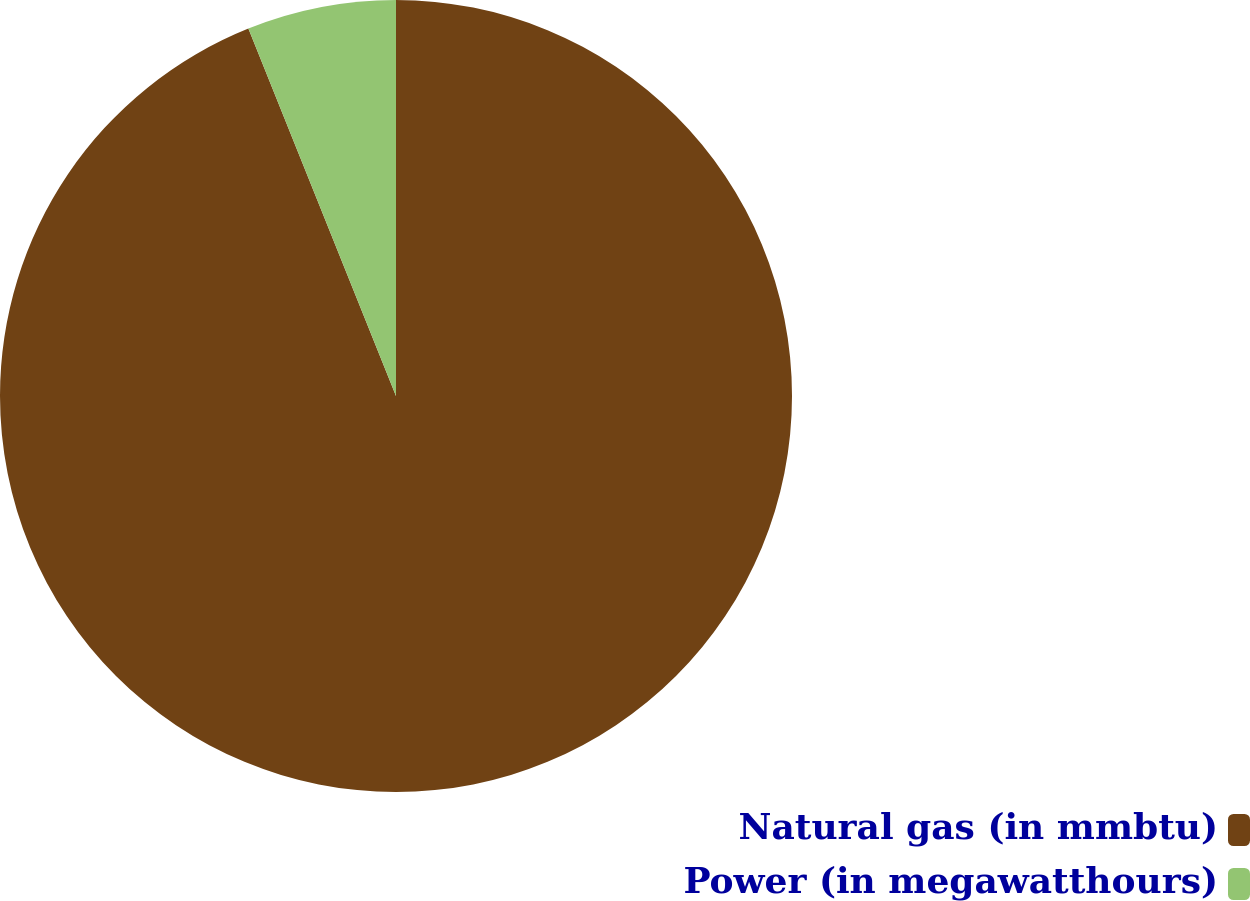Convert chart to OTSL. <chart><loc_0><loc_0><loc_500><loc_500><pie_chart><fcel>Natural gas (in mmbtu)<fcel>Power (in megawatthours)<nl><fcel>93.92%<fcel>6.08%<nl></chart> 